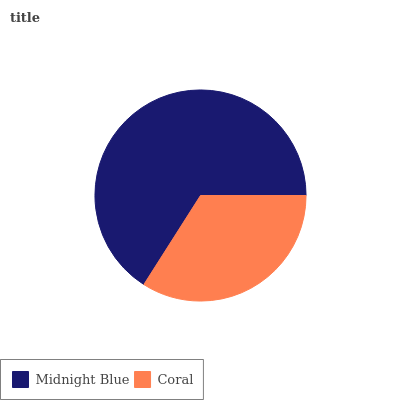Is Coral the minimum?
Answer yes or no. Yes. Is Midnight Blue the maximum?
Answer yes or no. Yes. Is Coral the maximum?
Answer yes or no. No. Is Midnight Blue greater than Coral?
Answer yes or no. Yes. Is Coral less than Midnight Blue?
Answer yes or no. Yes. Is Coral greater than Midnight Blue?
Answer yes or no. No. Is Midnight Blue less than Coral?
Answer yes or no. No. Is Midnight Blue the high median?
Answer yes or no. Yes. Is Coral the low median?
Answer yes or no. Yes. Is Coral the high median?
Answer yes or no. No. Is Midnight Blue the low median?
Answer yes or no. No. 